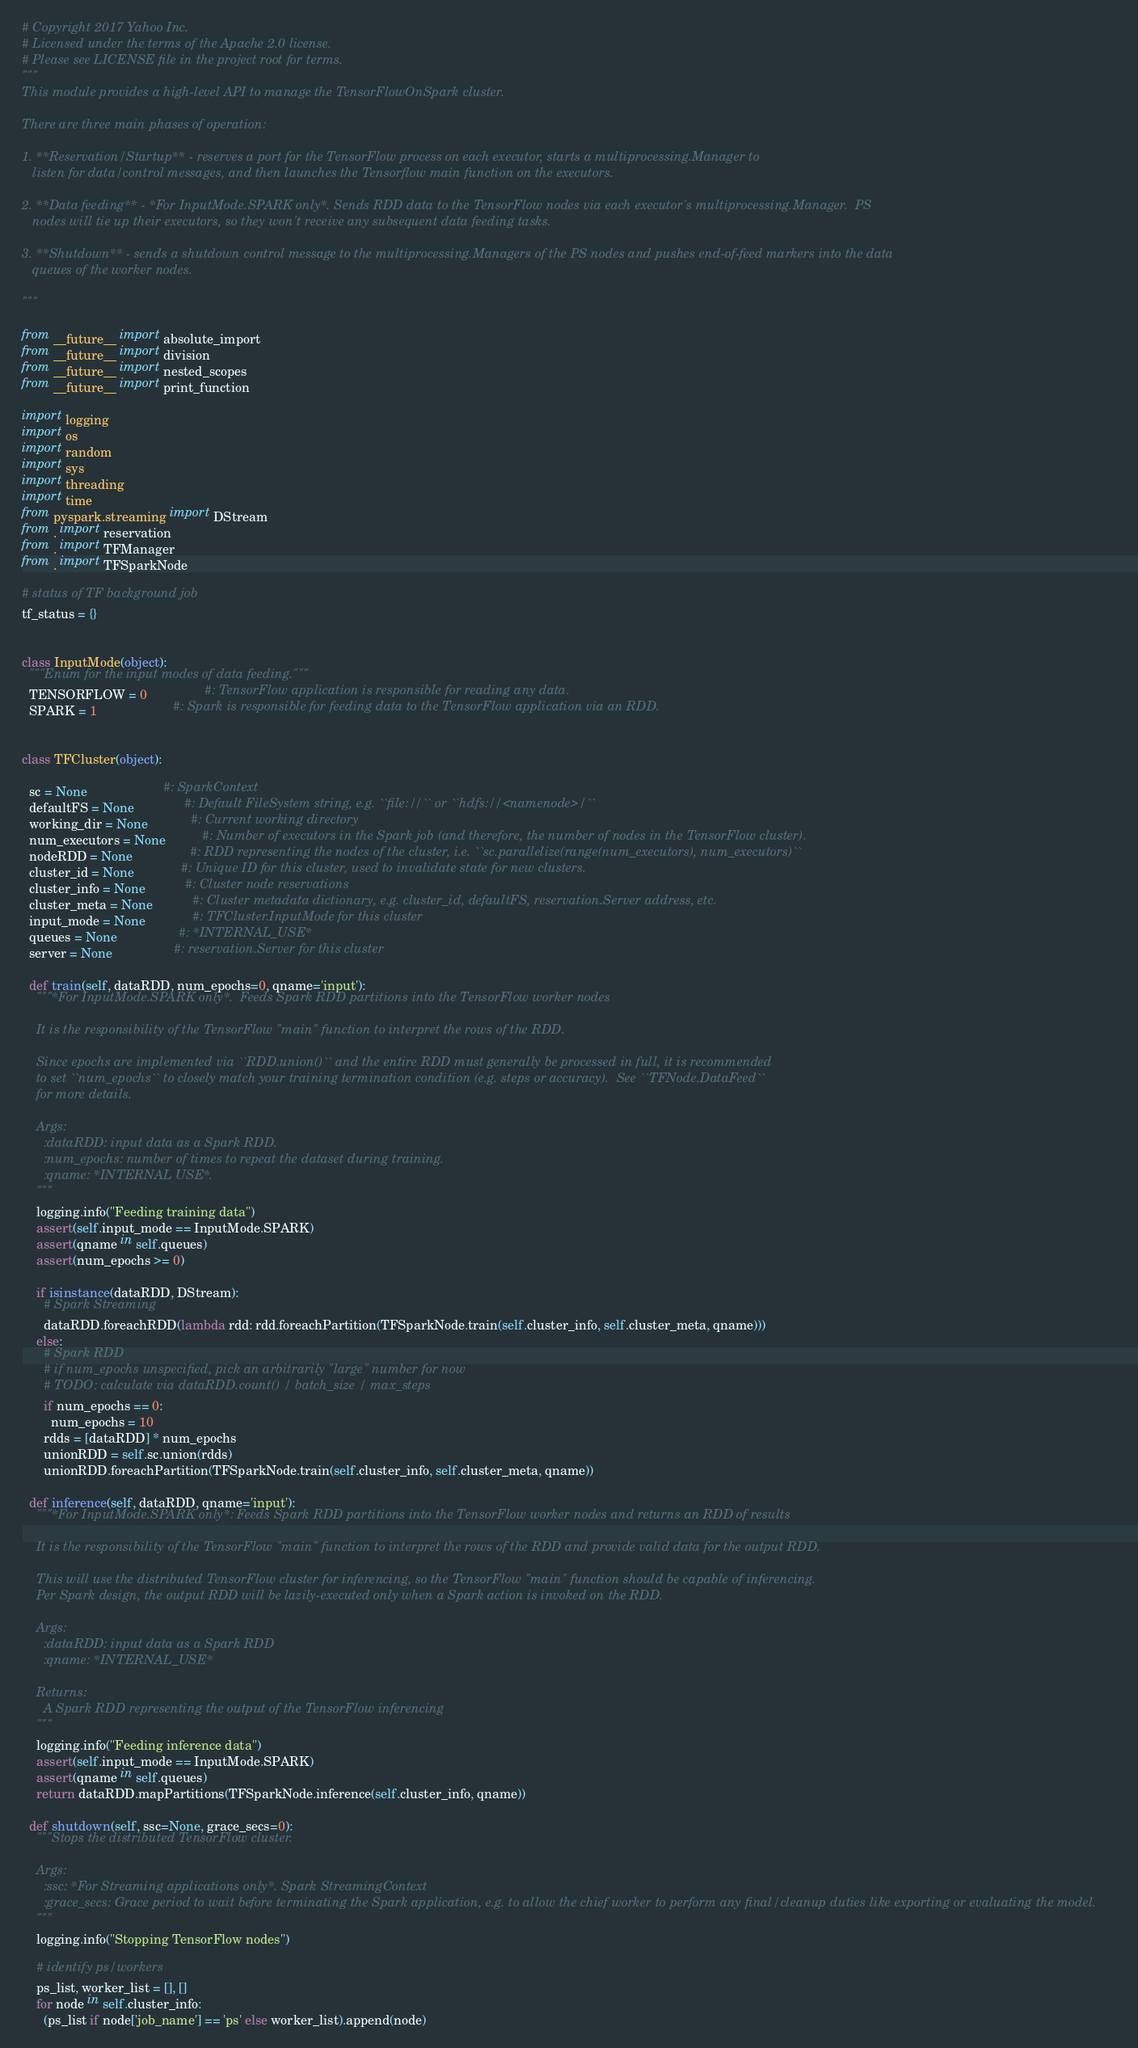Convert code to text. <code><loc_0><loc_0><loc_500><loc_500><_Python_># Copyright 2017 Yahoo Inc.
# Licensed under the terms of the Apache 2.0 license.
# Please see LICENSE file in the project root for terms.
"""
This module provides a high-level API to manage the TensorFlowOnSpark cluster.

There are three main phases of operation:

1. **Reservation/Startup** - reserves a port for the TensorFlow process on each executor, starts a multiprocessing.Manager to
   listen for data/control messages, and then launches the Tensorflow main function on the executors.

2. **Data feeding** - *For InputMode.SPARK only*. Sends RDD data to the TensorFlow nodes via each executor's multiprocessing.Manager.  PS
   nodes will tie up their executors, so they won't receive any subsequent data feeding tasks.

3. **Shutdown** - sends a shutdown control message to the multiprocessing.Managers of the PS nodes and pushes end-of-feed markers into the data
   queues of the worker nodes.

"""

from __future__ import absolute_import
from __future__ import division
from __future__ import nested_scopes
from __future__ import print_function

import logging
import os
import random
import sys
import threading
import time
from pyspark.streaming import DStream
from . import reservation
from . import TFManager
from . import TFSparkNode

# status of TF background job
tf_status = {}


class InputMode(object):
  """Enum for the input modes of data feeding."""
  TENSORFLOW = 0                #: TensorFlow application is responsible for reading any data.
  SPARK = 1                     #: Spark is responsible for feeding data to the TensorFlow application via an RDD.


class TFCluster(object):

  sc = None                     #: SparkContext
  defaultFS = None              #: Default FileSystem string, e.g. ``file://`` or ``hdfs://<namenode>/``
  working_dir = None            #: Current working directory
  num_executors = None          #: Number of executors in the Spark job (and therefore, the number of nodes in the TensorFlow cluster).
  nodeRDD = None                #: RDD representing the nodes of the cluster, i.e. ``sc.parallelize(range(num_executors), num_executors)``
  cluster_id = None             #: Unique ID for this cluster, used to invalidate state for new clusters.
  cluster_info = None           #: Cluster node reservations
  cluster_meta = None           #: Cluster metadata dictionary, e.g. cluster_id, defaultFS, reservation.Server address, etc.
  input_mode = None             #: TFCluster.InputMode for this cluster
  queues = None                 #: *INTERNAL_USE*
  server = None                 #: reservation.Server for this cluster

  def train(self, dataRDD, num_epochs=0, qname='input'):
    """*For InputMode.SPARK only*.  Feeds Spark RDD partitions into the TensorFlow worker nodes

    It is the responsibility of the TensorFlow "main" function to interpret the rows of the RDD.

    Since epochs are implemented via ``RDD.union()`` and the entire RDD must generally be processed in full, it is recommended
    to set ``num_epochs`` to closely match your training termination condition (e.g. steps or accuracy).  See ``TFNode.DataFeed``
    for more details.

    Args:
      :dataRDD: input data as a Spark RDD.
      :num_epochs: number of times to repeat the dataset during training.
      :qname: *INTERNAL USE*.
    """
    logging.info("Feeding training data")
    assert(self.input_mode == InputMode.SPARK)
    assert(qname in self.queues)
    assert(num_epochs >= 0)

    if isinstance(dataRDD, DStream):
      # Spark Streaming
      dataRDD.foreachRDD(lambda rdd: rdd.foreachPartition(TFSparkNode.train(self.cluster_info, self.cluster_meta, qname)))
    else:
      # Spark RDD
      # if num_epochs unspecified, pick an arbitrarily "large" number for now
      # TODO: calculate via dataRDD.count() / batch_size / max_steps
      if num_epochs == 0:
        num_epochs = 10
      rdds = [dataRDD] * num_epochs
      unionRDD = self.sc.union(rdds)
      unionRDD.foreachPartition(TFSparkNode.train(self.cluster_info, self.cluster_meta, qname))

  def inference(self, dataRDD, qname='input'):
    """*For InputMode.SPARK only*: Feeds Spark RDD partitions into the TensorFlow worker nodes and returns an RDD of results

    It is the responsibility of the TensorFlow "main" function to interpret the rows of the RDD and provide valid data for the output RDD.

    This will use the distributed TensorFlow cluster for inferencing, so the TensorFlow "main" function should be capable of inferencing.
    Per Spark design, the output RDD will be lazily-executed only when a Spark action is invoked on the RDD.

    Args:
      :dataRDD: input data as a Spark RDD
      :qname: *INTERNAL_USE*

    Returns:
      A Spark RDD representing the output of the TensorFlow inferencing
    """
    logging.info("Feeding inference data")
    assert(self.input_mode == InputMode.SPARK)
    assert(qname in self.queues)
    return dataRDD.mapPartitions(TFSparkNode.inference(self.cluster_info, qname))

  def shutdown(self, ssc=None, grace_secs=0):
    """Stops the distributed TensorFlow cluster.

    Args:
      :ssc: *For Streaming applications only*. Spark StreamingContext
      :grace_secs: Grace period to wait before terminating the Spark application, e.g. to allow the chief worker to perform any final/cleanup duties like exporting or evaluating the model.
    """
    logging.info("Stopping TensorFlow nodes")

    # identify ps/workers
    ps_list, worker_list = [], []
    for node in self.cluster_info:
      (ps_list if node['job_name'] == 'ps' else worker_list).append(node)
</code> 